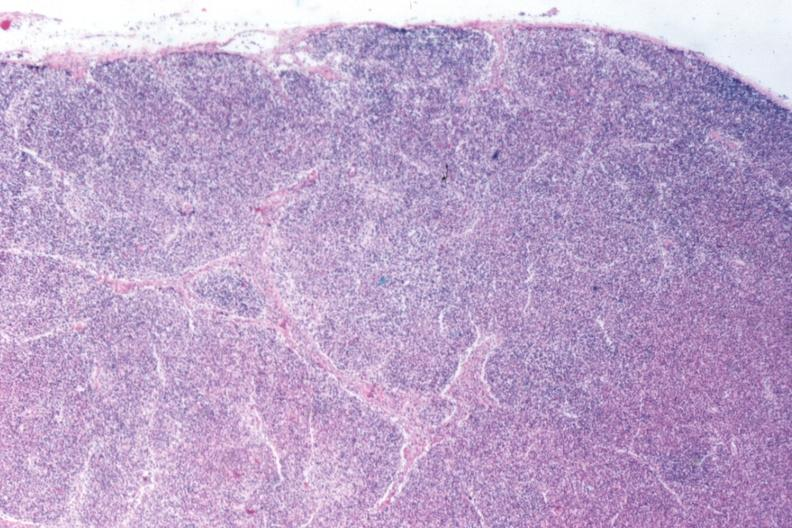s exposure present?
Answer the question using a single word or phrase. No 